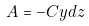<formula> <loc_0><loc_0><loc_500><loc_500>A = - C y d z</formula> 